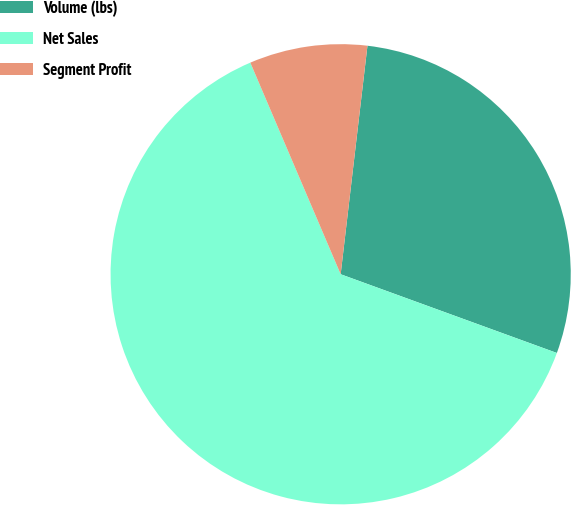Convert chart to OTSL. <chart><loc_0><loc_0><loc_500><loc_500><pie_chart><fcel>Volume (lbs)<fcel>Net Sales<fcel>Segment Profit<nl><fcel>28.7%<fcel>63.02%<fcel>8.28%<nl></chart> 